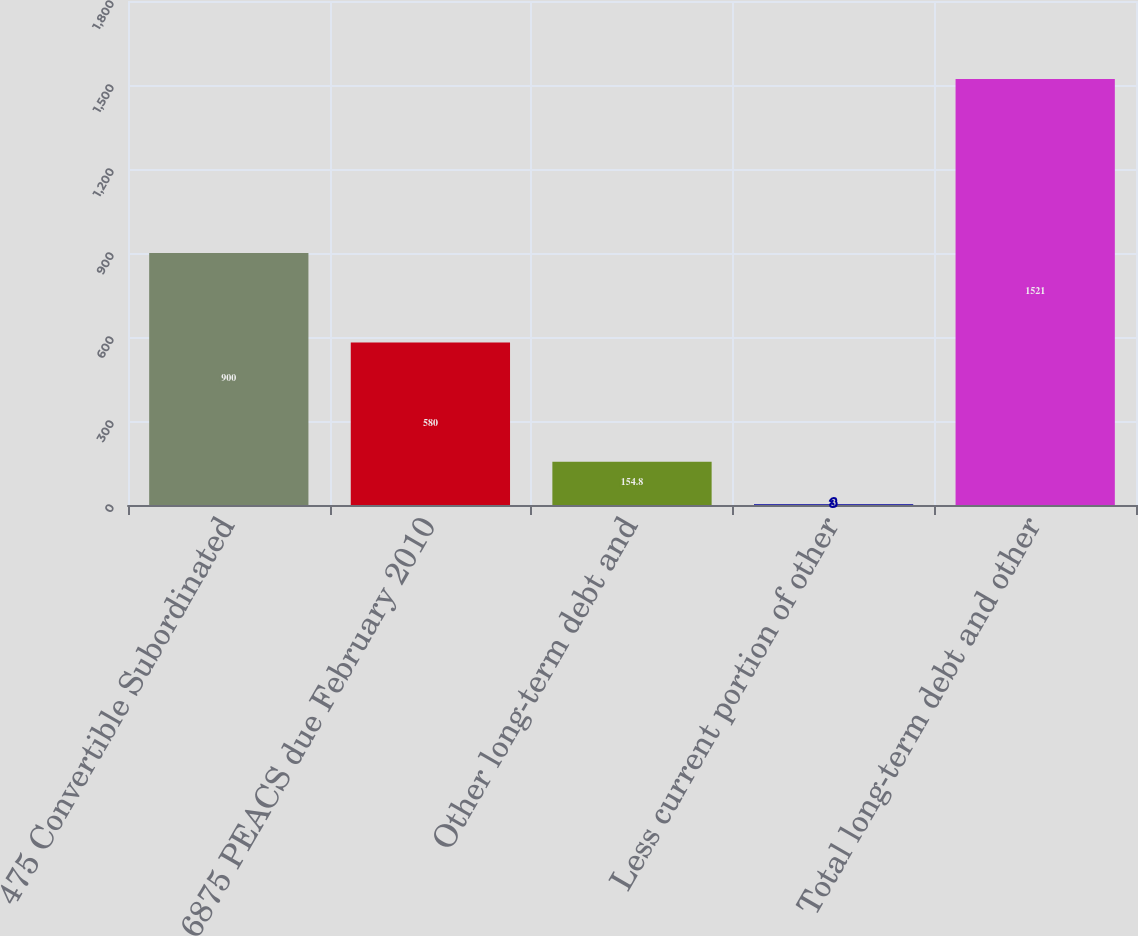<chart> <loc_0><loc_0><loc_500><loc_500><bar_chart><fcel>475 Convertible Subordinated<fcel>6875 PEACS due February 2010<fcel>Other long-term debt and<fcel>Less current portion of other<fcel>Total long-term debt and other<nl><fcel>900<fcel>580<fcel>154.8<fcel>3<fcel>1521<nl></chart> 